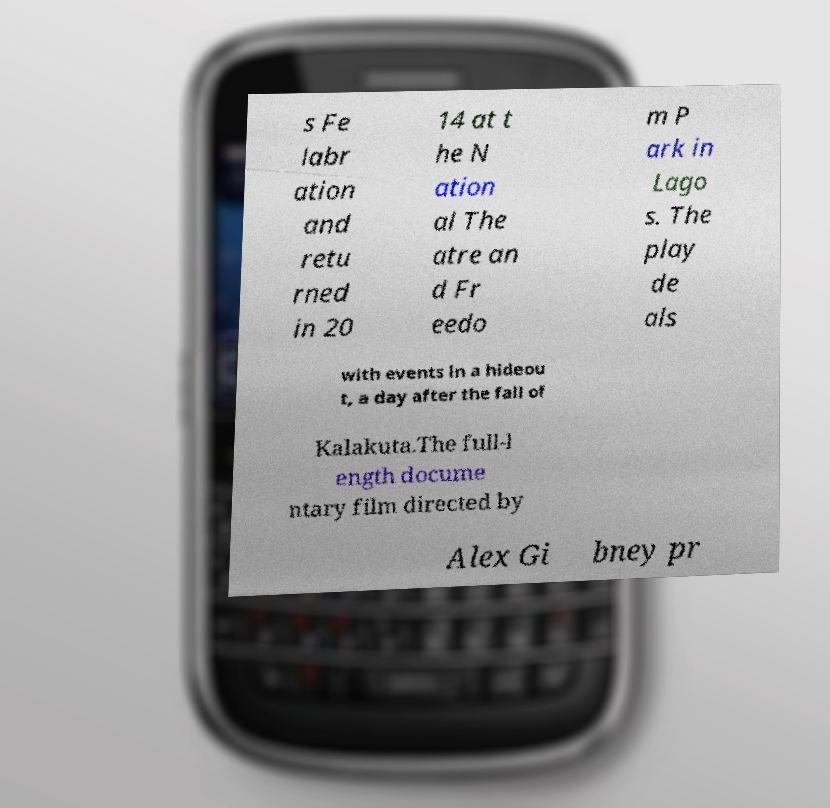What messages or text are displayed in this image? I need them in a readable, typed format. s Fe labr ation and retu rned in 20 14 at t he N ation al The atre an d Fr eedo m P ark in Lago s. The play de als with events in a hideou t, a day after the fall of Kalakuta.The full-l ength docume ntary film directed by Alex Gi bney pr 